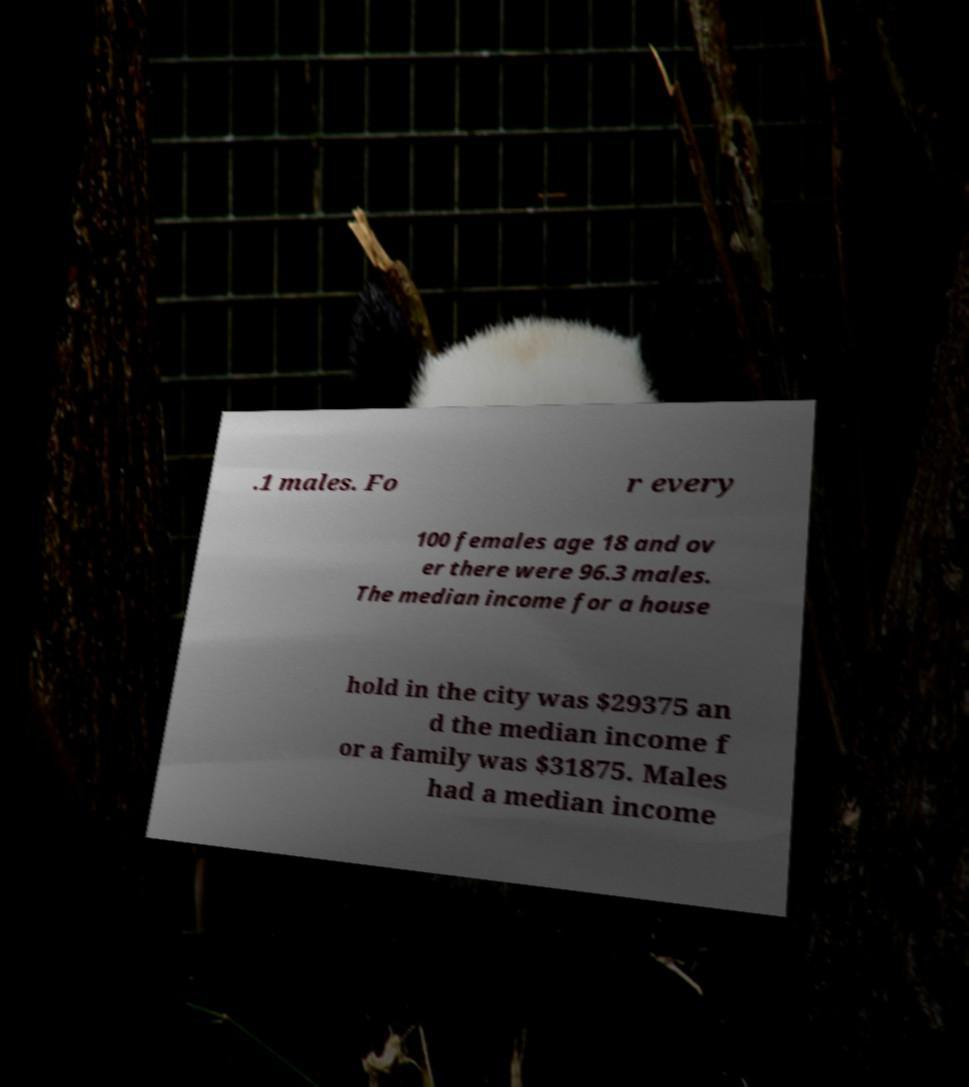For documentation purposes, I need the text within this image transcribed. Could you provide that? .1 males. Fo r every 100 females age 18 and ov er there were 96.3 males. The median income for a house hold in the city was $29375 an d the median income f or a family was $31875. Males had a median income 